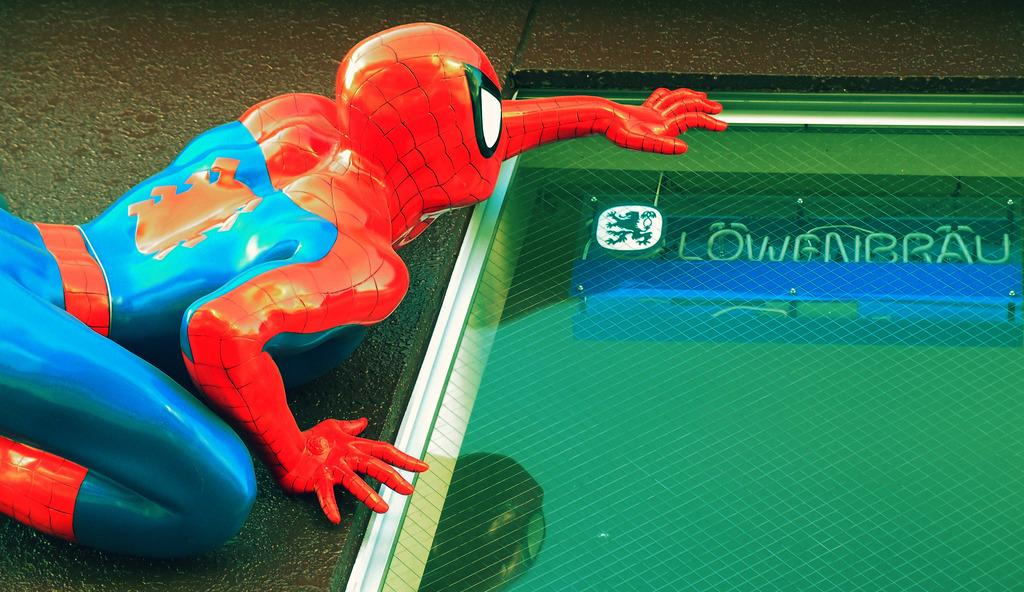What type of toy is in the image? There is a Spider-Man toy in the image. What feature can be seen on the toy? There is a window on the right side of the toy. What is visible behind the window? There is a name board, a logo, and screws visible behind the window. What animal can be seen making a discovery in the image? There are no animals or discoveries present in the image. What division of labor is depicted in the image? There is no division of labor depicted in the image; it features a Spider-Man toy with a window and items visible behind it. 